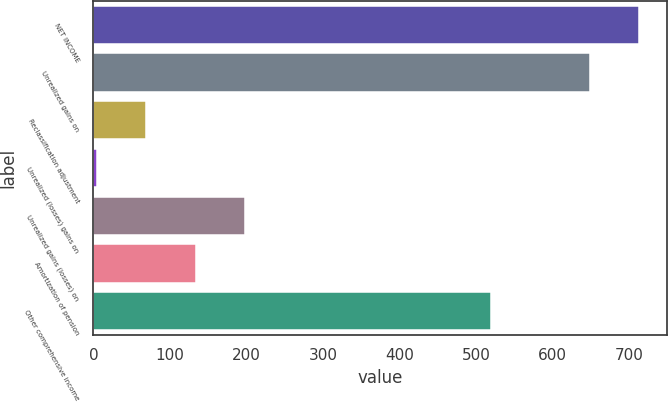Convert chart to OTSL. <chart><loc_0><loc_0><loc_500><loc_500><bar_chart><fcel>NET INCOME<fcel>Unrealized gains on<fcel>Reclassification adjustment<fcel>Unrealized (losses) gains on<fcel>Unrealized gains (losses) on<fcel>Amortization of pension<fcel>Other comprehensive income<nl><fcel>713.4<fcel>649<fcel>69.4<fcel>5<fcel>198.2<fcel>133.8<fcel>520.2<nl></chart> 